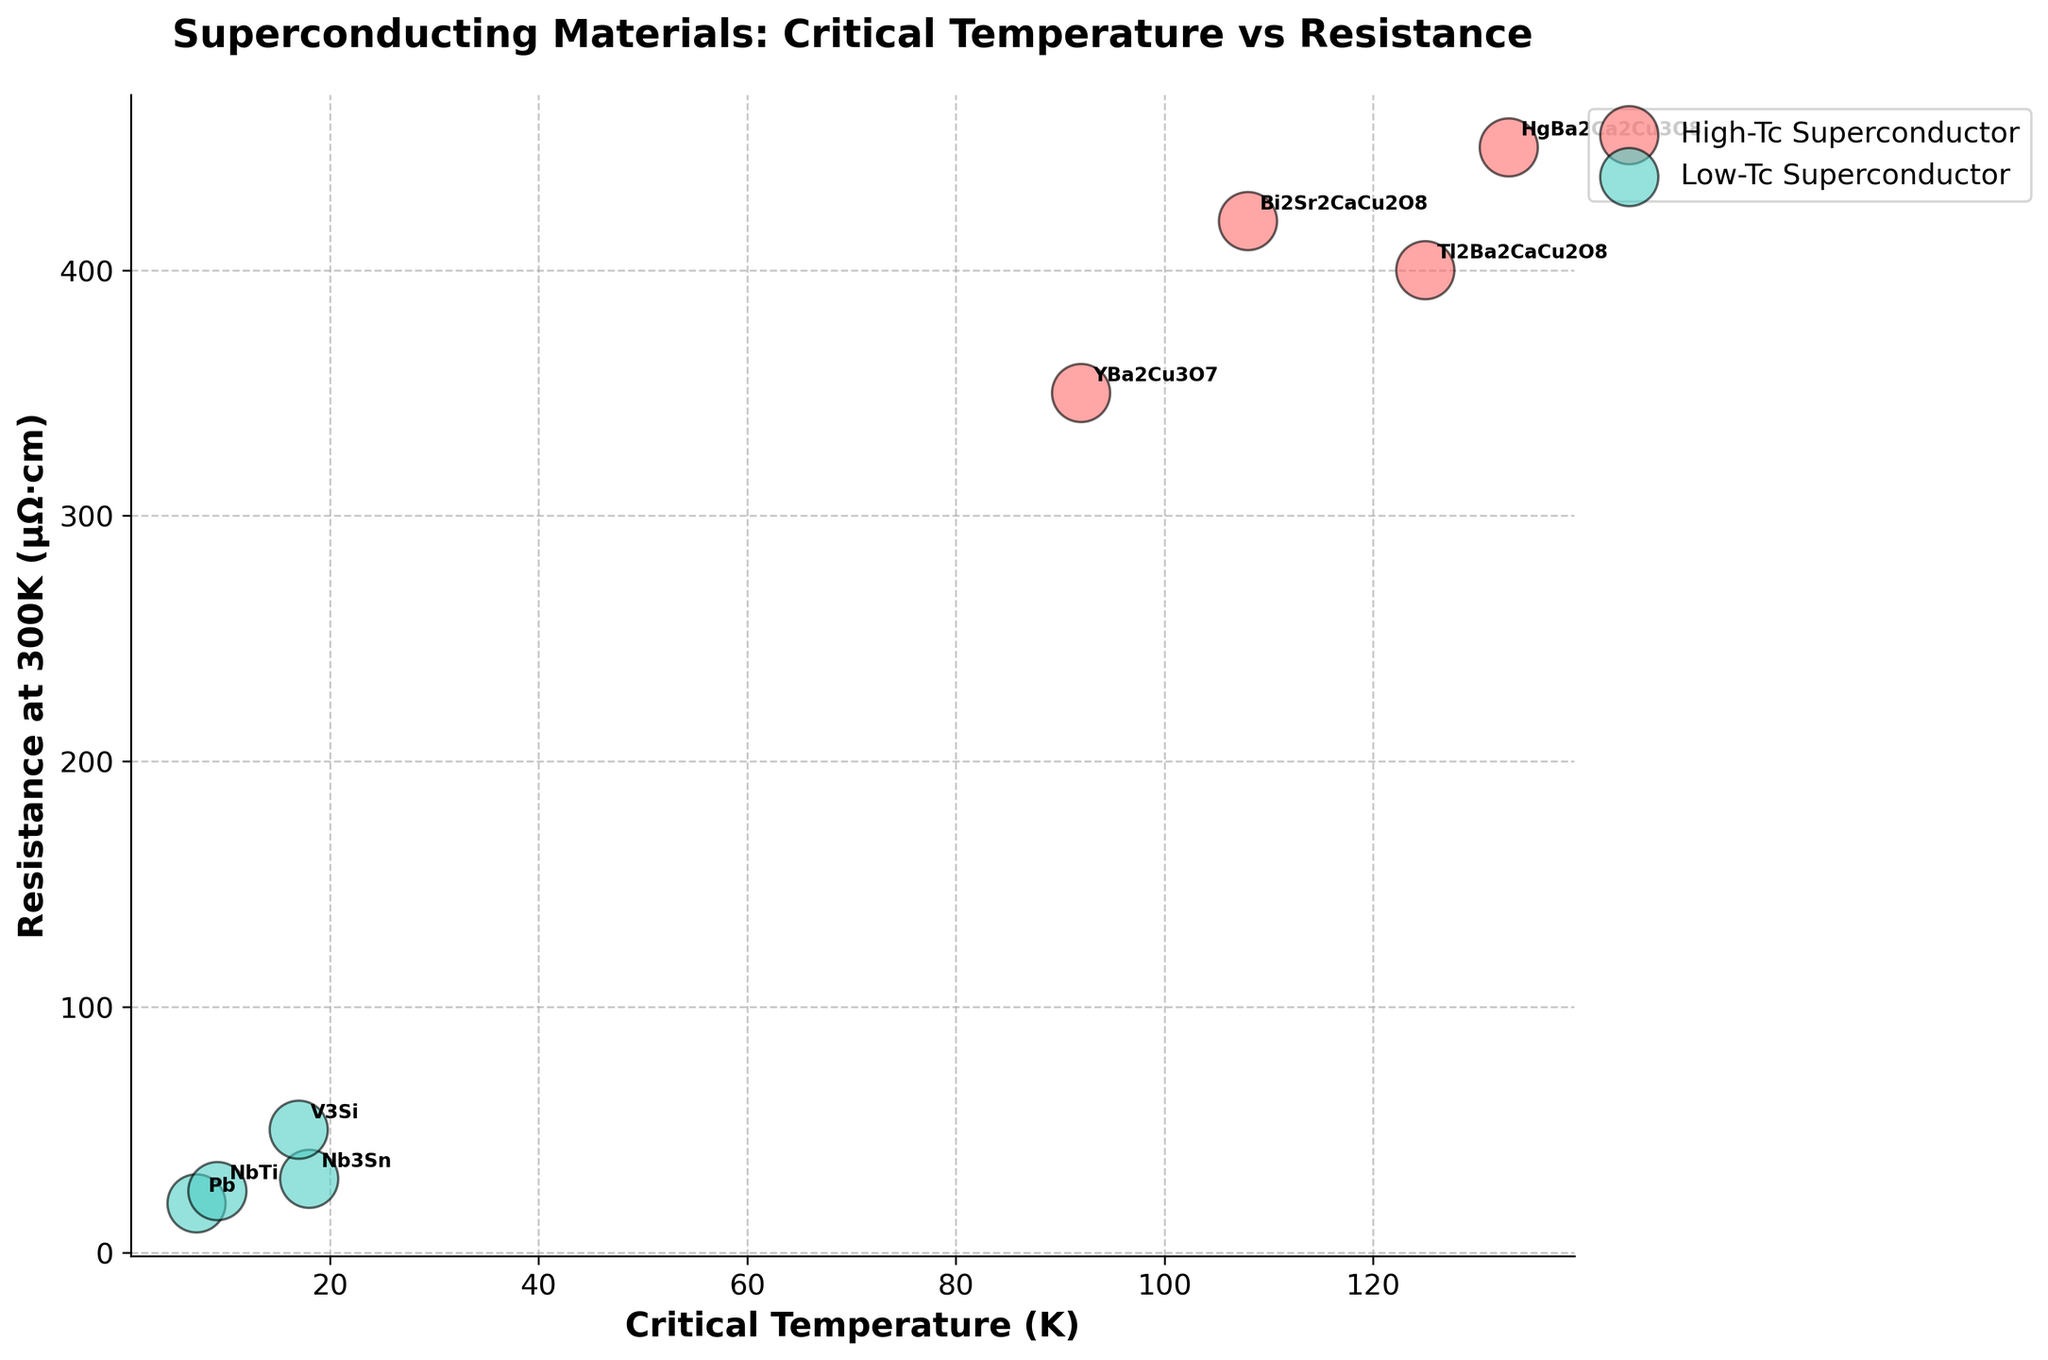What is the color used to represent High-Tc Superconductors? The bubble chart uses two different colors to represent different types of superconductors. By observing the chart, we see that the color used for High-Tc Superconductors is typically a bright red shade.
Answer: Red What is the title of the bubble chart? The title of the bubble chart is displayed prominently at the top of the figure. It succinctly describes the key variables and context of the chart.
Answer: Superconducting Materials: Critical Temperature vs Resistance Which superconducting material has the highest critical temperature? By examining the critical temperatures plotted on the x-axis, we find that 'HgBa2Ca2Cu3O8' has the highest critical temperature which is highlighted near the upper right part of the plot.
Answer: HgBa2Ca2Cu3O8 What can you deduce about the resistance at 300K for High-Tc Superconductors compared to Low-Tc Superconductors? Observing the vertical spread of bubbles, we can see that High-Tc Superconductors generally have higher resistance at 300K. This includes materials like YBa2Cu3O7, HgBa2Ca2Cu3O8, Bi2Sr2CaCu2O8, and Tl2Ba2CaCu2O8, compared to Low-Tc Superconductors like Nb3Sn, Pb, NbTi, and V3Si.
Answer: Higher How does the bubble size vary among the materials, and what does it represent? The bubble size in the chart varies significantly, with each bubble's size proportional to its temperature (K). Hence, materials like YBa2Cu3O7, represented by larger bubbles, indicate higher temperatures compared to smaller bubbles representing materials like V3Si.
Answer: Proportional to temperature What is the trend in resistance at 300K with respect to critical temperature among High-Tc Superconductors? In the bubble chart, we can observe that within the High-Tc Superconductors group, as the critical temperature increases, there is a general trend of increasing resistance at 300K as well, although some variation exists.
Answer: Increasing Compare the resistance at 300K between Nb3Sn and V3Si. From the vertical positions of the bubbles on the y-axis, it is evident that V3Si has a higher resistance at 300K (50 µΩ·cm) compared to Nb3Sn (30 µΩ·cm).
Answer: V3Si has higher What is the average critical temperature for all Low-Tc Superconductors shown in the chart? Examining the x-axis positions for Low-Tc Superconductors (Nb3Sn, Pb, NbTi, V3Si), their critical temperatures are 18K, 7.2K, 9.2K, and 17K respectively. Summing these values (18 + 7.2 + 9.2 + 17) gives 51.4K. Dividing by the number of samples (4), the average is 12.85K.
Answer: 12.85K Which three materials have similar critical temperatures but different resistances at 300K? Observing the bubble positions along the x-axis, Bi2Sr2CaCu2O8 (108K), HgBa2Ca2Cu3O8 (133K), and Tl2Ba2CaCu2O8 (125K) have close critical temperatures. However, their resistances at 300K are different: 420 µΩ·cm, 450 µΩ·cm, and 400 µΩ·cm, respectively.
Answer: Bi2Sr2CaCu2O8, HgBa2Ca2Cu3O8, Tl2Ba2CaCu2O8 Identify the material type with larger bubble sizes on average and explain what it indicates about their temperatures. High-Tc Superconductors tend to have larger bubble sizes in the chart. This indicates that their temperatures (K) when the resistance is measured are generally higher compared to Low-Tc Superconductors.
Answer: High-Tc means higher temperatures 